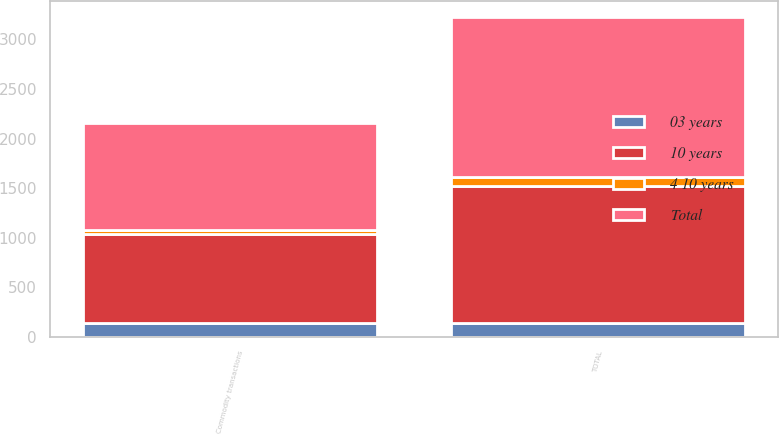Convert chart to OTSL. <chart><loc_0><loc_0><loc_500><loc_500><stacked_bar_chart><ecel><fcel>Commodity transactions<fcel>TOTAL<nl><fcel>10 years<fcel>895<fcel>1379<nl><fcel>4 10 years<fcel>43<fcel>89<nl><fcel>03 years<fcel>143<fcel>144<nl><fcel>Total<fcel>1081<fcel>1612<nl></chart> 